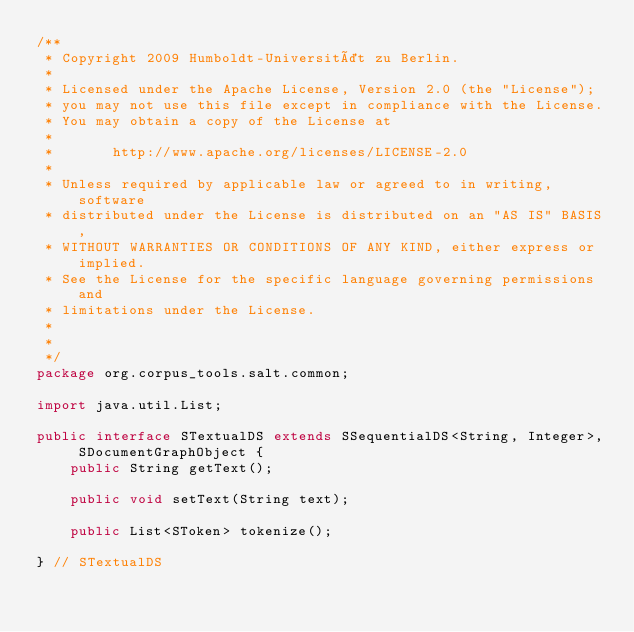Convert code to text. <code><loc_0><loc_0><loc_500><loc_500><_Java_>/**
 * Copyright 2009 Humboldt-Universität zu Berlin.
 *
 * Licensed under the Apache License, Version 2.0 (the "License");
 * you may not use this file except in compliance with the License.
 * You may obtain a copy of the License at
 *
 *       http://www.apache.org/licenses/LICENSE-2.0
 *
 * Unless required by applicable law or agreed to in writing, software
 * distributed under the License is distributed on an "AS IS" BASIS,
 * WITHOUT WARRANTIES OR CONDITIONS OF ANY KIND, either express or implied.
 * See the License for the specific language governing permissions and
 * limitations under the License.
 *
 *
 */
package org.corpus_tools.salt.common;

import java.util.List;

public interface STextualDS extends SSequentialDS<String, Integer>, SDocumentGraphObject {
	public String getText();

	public void setText(String text);

	public List<SToken> tokenize();

} // STextualDS
</code> 